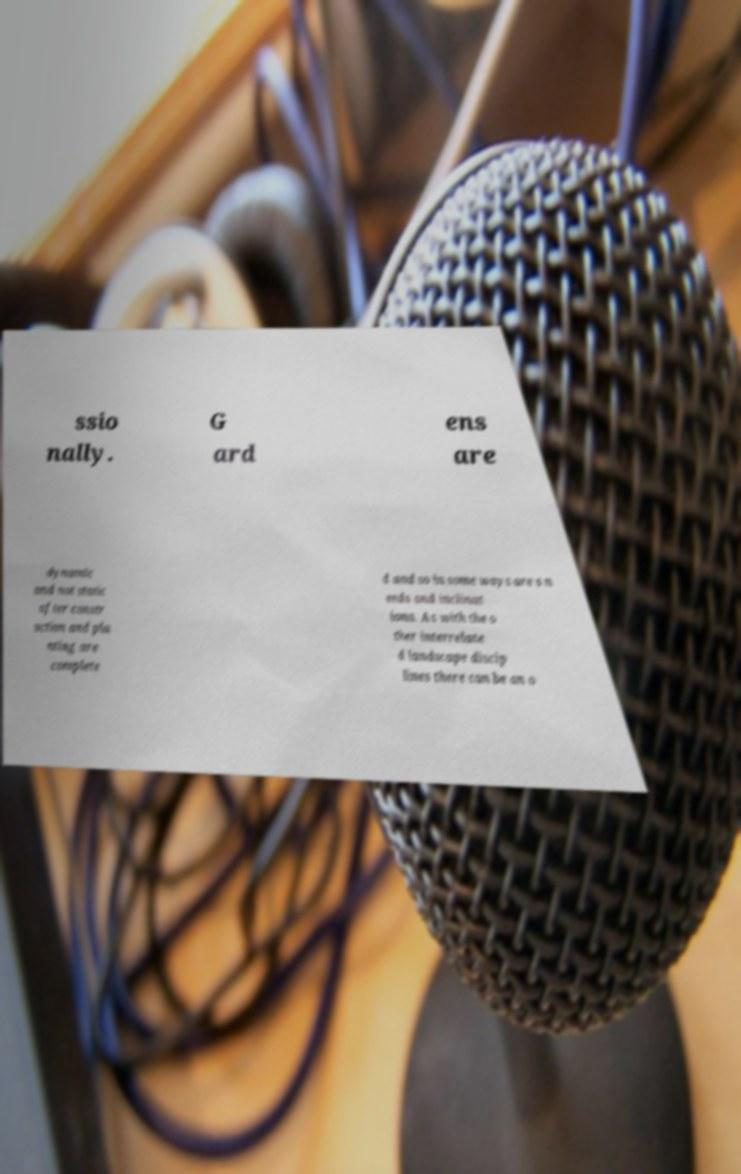What messages or text are displayed in this image? I need them in a readable, typed format. ssio nally. G ard ens are dynamic and not static after constr uction and pla nting are complete d and so in some ways are s n eeds and inclinat ions. As with the o ther interrelate d landscape discip lines there can be an o 